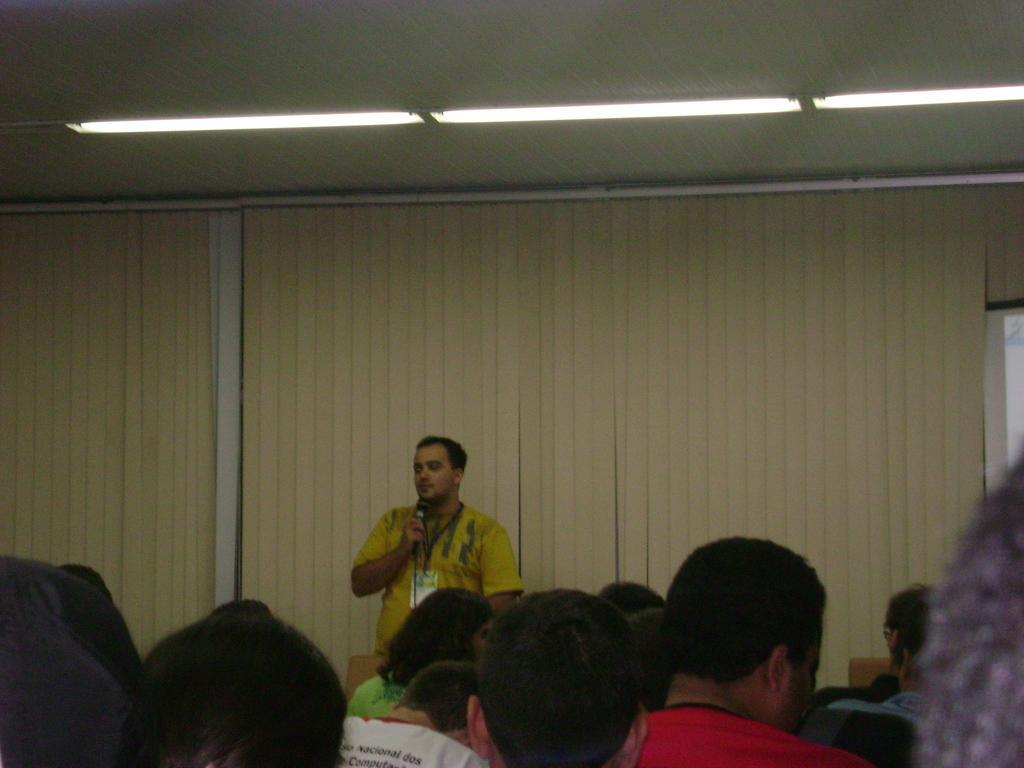In one or two sentences, can you explain what this image depicts? In this picture we can see a group of people and in front of them we can see a man holding a mic with his hand and in the background we can see the lights, curtains. 